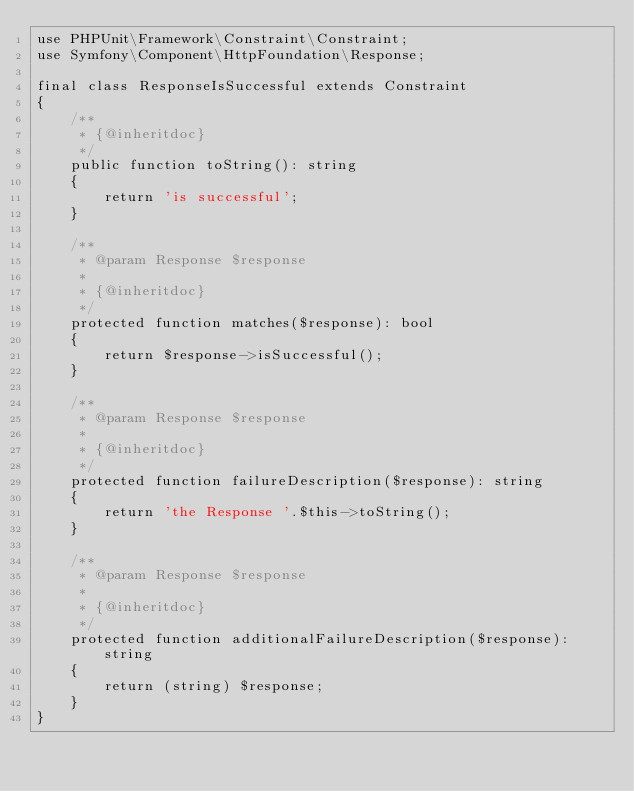<code> <loc_0><loc_0><loc_500><loc_500><_PHP_>use PHPUnit\Framework\Constraint\Constraint;
use Symfony\Component\HttpFoundation\Response;

final class ResponseIsSuccessful extends Constraint
{
    /**
     * {@inheritdoc}
     */
    public function toString(): string
    {
        return 'is successful';
    }

    /**
     * @param Response $response
     *
     * {@inheritdoc}
     */
    protected function matches($response): bool
    {
        return $response->isSuccessful();
    }

    /**
     * @param Response $response
     *
     * {@inheritdoc}
     */
    protected function failureDescription($response): string
    {
        return 'the Response '.$this->toString();
    }

    /**
     * @param Response $response
     *
     * {@inheritdoc}
     */
    protected function additionalFailureDescription($response): string
    {
        return (string) $response;
    }
}
</code> 